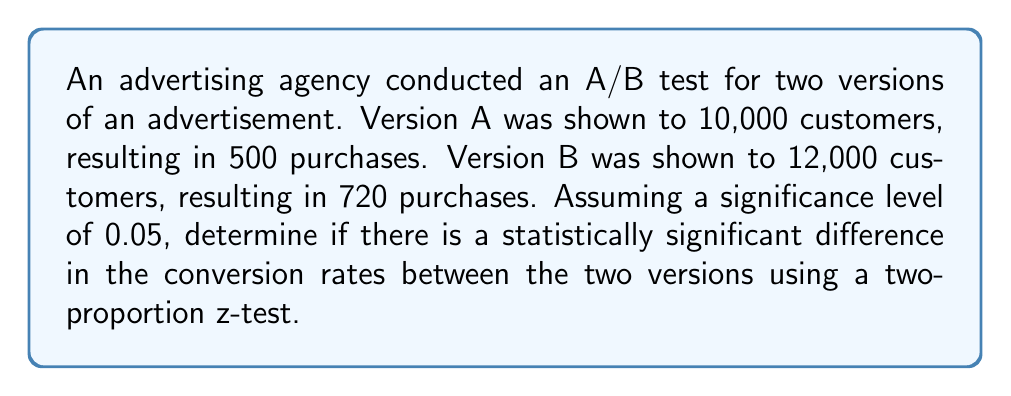Give your solution to this math problem. To analyze the effectiveness of A/B testing in this advertising campaign, we'll use a two-proportion z-test. Let's follow these steps:

1. Define the null and alternative hypotheses:
   $H_0: p_A = p_B$ (no difference in conversion rates)
   $H_a: p_A \neq p_B$ (there is a difference in conversion rates)

2. Calculate the sample proportions:
   $\hat{p}_A = \frac{500}{10000} = 0.05$
   $\hat{p}_B = \frac{720}{12000} = 0.06$

3. Calculate the pooled proportion:
   $\hat{p} = \frac{500 + 720}{10000 + 12000} = \frac{1220}{22000} \approx 0.0555$

4. Calculate the standard error:
   $SE = \sqrt{\hat{p}(1-\hat{p})(\frac{1}{n_A} + \frac{1}{n_B})}$
   $SE = \sqrt{0.0555(1-0.0555)(\frac{1}{10000} + \frac{1}{12000})} \approx 0.00316$

5. Calculate the z-score:
   $z = \frac{\hat{p}_B - \hat{p}_A}{SE} = \frac{0.06 - 0.05}{0.00316} \approx 3.16$

6. Find the critical value for a two-tailed test at α = 0.05:
   $z_{critical} = \pm 1.96$

7. Compare the calculated z-score to the critical value:
   $|3.16| > 1.96$

8. Calculate the p-value:
   $p-value = 2 \times P(Z > 3.16) \approx 0.0016$

Since the absolute value of the calculated z-score (3.16) is greater than the critical value (1.96), and the p-value (0.0016) is less than the significance level (0.05), we reject the null hypothesis.
Answer: Statistically significant difference (p-value ≈ 0.0016 < 0.05) 